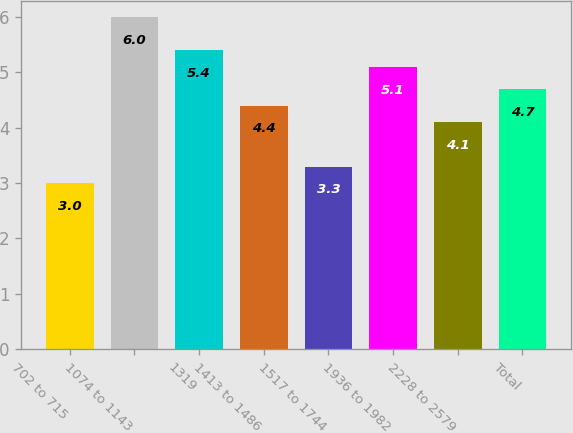Convert chart. <chart><loc_0><loc_0><loc_500><loc_500><bar_chart><fcel>702 to 715<fcel>1074 to 1143<fcel>1319<fcel>1413 to 1486<fcel>1517 to 1744<fcel>1936 to 1982<fcel>2228 to 2579<fcel>Total<nl><fcel>3<fcel>6<fcel>5.4<fcel>4.4<fcel>3.3<fcel>5.1<fcel>4.1<fcel>4.7<nl></chart> 